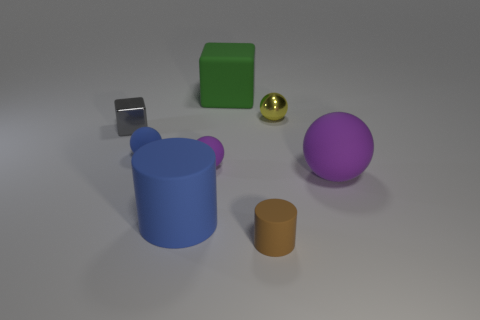What number of other things are the same material as the brown cylinder?
Make the answer very short. 5. Are there the same number of green objects in front of the rubber cube and purple cylinders?
Provide a succinct answer. Yes. What material is the small object in front of the thing to the right of the tiny metal object that is behind the gray metal cube?
Make the answer very short. Rubber. What color is the sphere behind the tiny blue matte object?
Offer a very short reply. Yellow. Are there any other things that are the same shape as the tiny purple matte object?
Provide a short and direct response. Yes. There is a rubber cylinder that is left of the cylinder that is to the right of the large matte cube; how big is it?
Make the answer very short. Large. Is the number of gray shiny blocks that are behind the matte cube the same as the number of big things behind the small yellow ball?
Your answer should be very brief. No. Is there any other thing that has the same size as the gray shiny object?
Your response must be concise. Yes. There is a tiny cube that is made of the same material as the yellow sphere; what color is it?
Make the answer very short. Gray. Are the blue sphere and the tiny purple ball behind the large rubber ball made of the same material?
Give a very brief answer. Yes. 